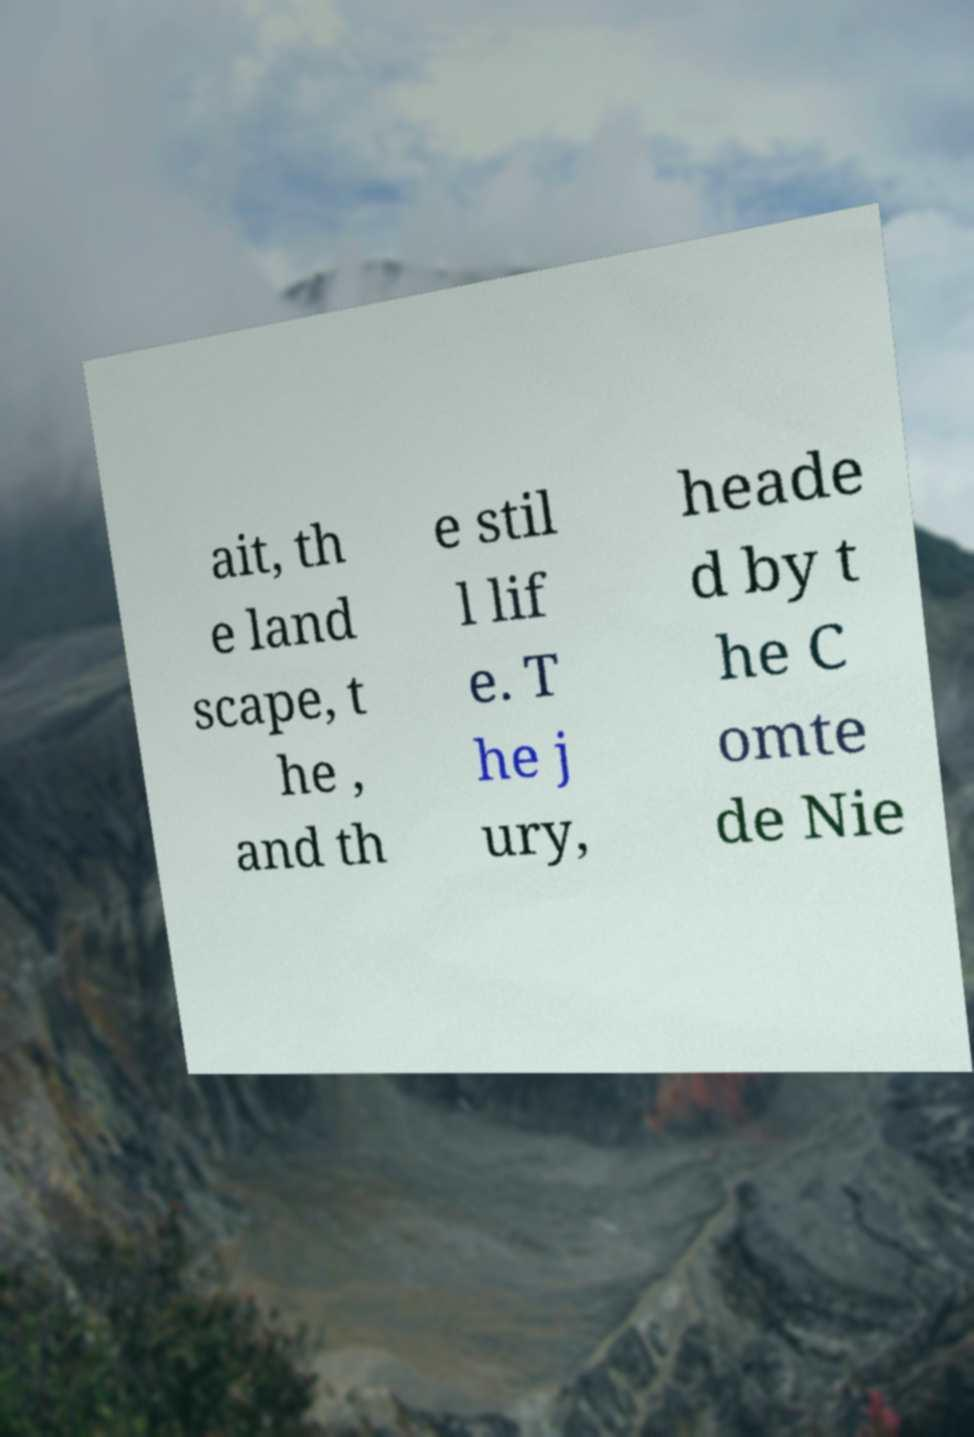Please identify and transcribe the text found in this image. ait, th e land scape, t he , and th e stil l lif e. T he j ury, heade d by t he C omte de Nie 